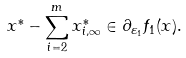<formula> <loc_0><loc_0><loc_500><loc_500>x ^ { * } - \sum _ { i = 2 } ^ { m } x _ { i , \infty } ^ { * } \in \partial _ { \varepsilon _ { 1 } } f _ { 1 } ( x ) .</formula> 